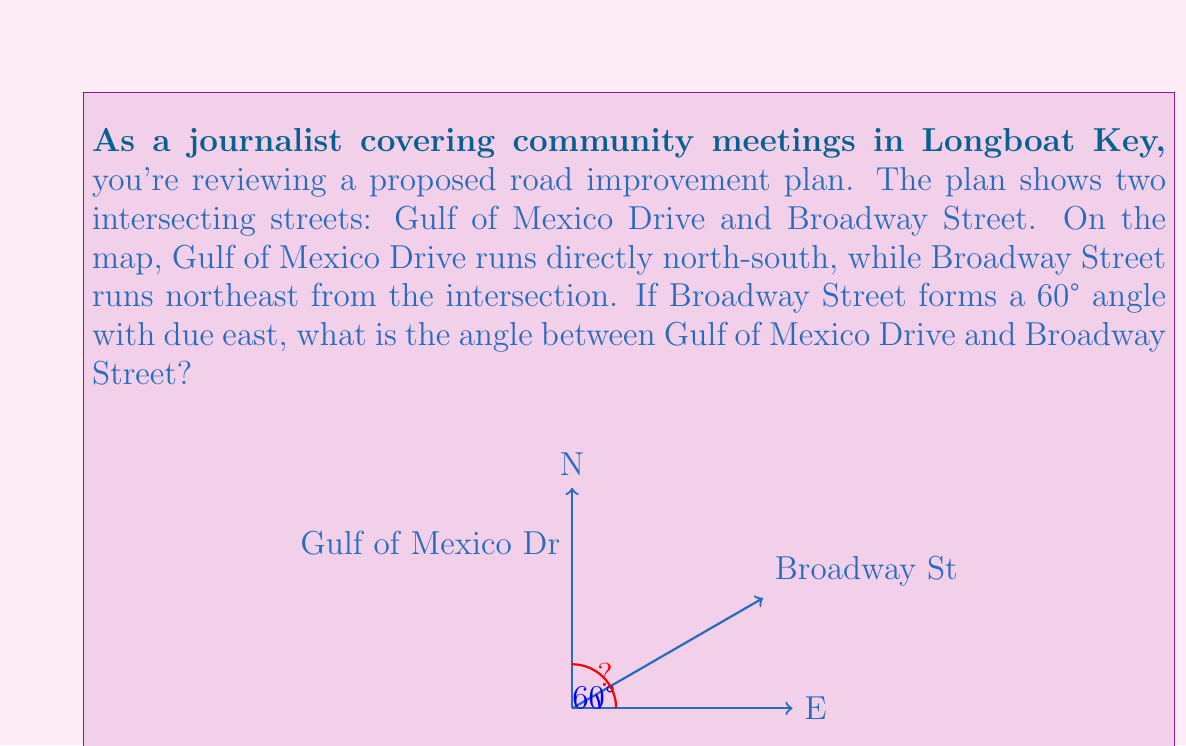Provide a solution to this math problem. To solve this problem, we need to understand the relationship between the given angles and the angle we're looking for. Let's break it down step-by-step:

1) Gulf of Mexico Drive runs north-south, which means it forms a 90° angle with due east.

2) Broadway Street forms a 60° angle with due east.

3) The angle we're looking for is the difference between these two angles.

4) We can calculate this difference using the following equation:

   $$\text{Angle between streets} = 90° - 60° = 30°$$

This calculation works because:
- The north-south street (Gulf of Mexico Drive) is at 90° from east.
- The northeast street (Broadway Street) is at 60° from east.
- The angle between them is the difference of these two angles.

Visualizing this on a compass rose can help:
- North is at 90°
- Northeast is at 45°
- Broadway Street is at 60°, which is between northeast and north

Therefore, the angle between Gulf of Mexico Drive and Broadway Street is 30°.
Answer: The angle between Gulf of Mexico Drive and Broadway Street is 30°. 